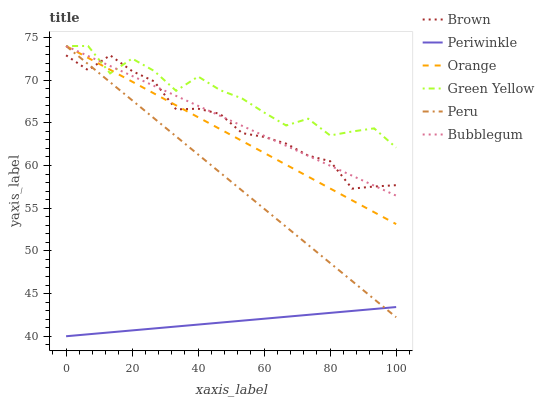Does Bubblegum have the minimum area under the curve?
Answer yes or no. No. Does Bubblegum have the maximum area under the curve?
Answer yes or no. No. Is Bubblegum the smoothest?
Answer yes or no. No. Is Bubblegum the roughest?
Answer yes or no. No. Does Bubblegum have the lowest value?
Answer yes or no. No. Does Periwinkle have the highest value?
Answer yes or no. No. Is Periwinkle less than Orange?
Answer yes or no. Yes. Is Brown greater than Periwinkle?
Answer yes or no. Yes. Does Periwinkle intersect Orange?
Answer yes or no. No. 